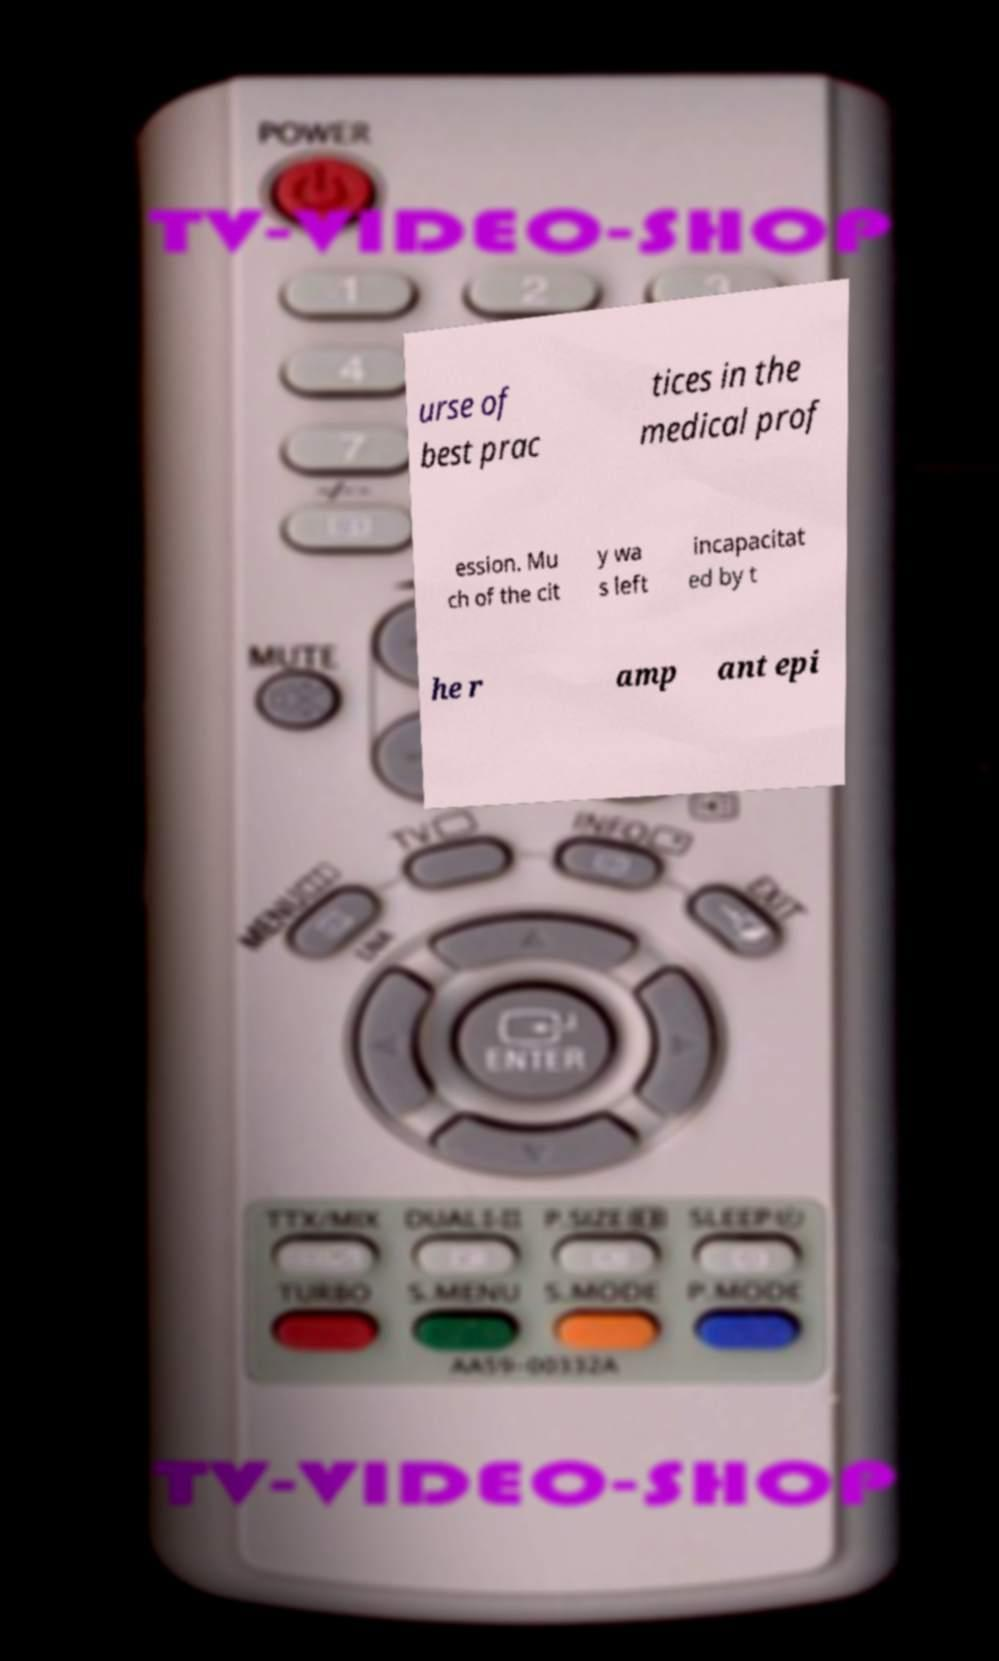Can you read and provide the text displayed in the image?This photo seems to have some interesting text. Can you extract and type it out for me? urse of best prac tices in the medical prof ession. Mu ch of the cit y wa s left incapacitat ed by t he r amp ant epi 